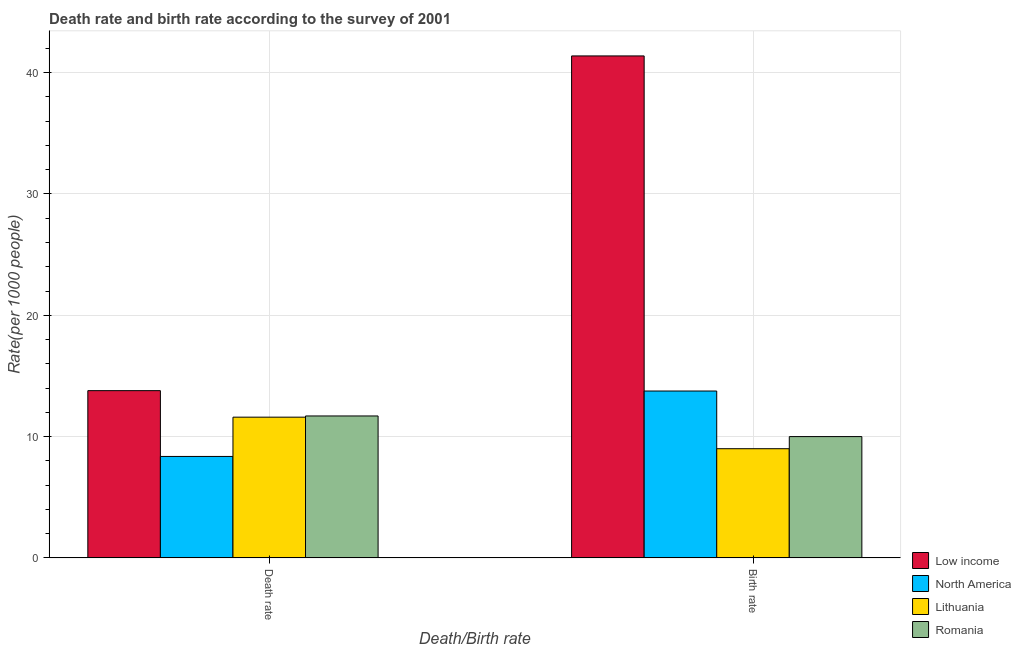How many different coloured bars are there?
Provide a succinct answer. 4. How many groups of bars are there?
Ensure brevity in your answer.  2. Are the number of bars per tick equal to the number of legend labels?
Give a very brief answer. Yes. Are the number of bars on each tick of the X-axis equal?
Make the answer very short. Yes. How many bars are there on the 1st tick from the right?
Offer a terse response. 4. What is the label of the 1st group of bars from the left?
Offer a terse response. Death rate. What is the birth rate in Low income?
Provide a succinct answer. 41.38. Across all countries, what is the maximum birth rate?
Provide a succinct answer. 41.38. Across all countries, what is the minimum birth rate?
Give a very brief answer. 9. In which country was the death rate maximum?
Your answer should be compact. Low income. In which country was the birth rate minimum?
Give a very brief answer. Lithuania. What is the total death rate in the graph?
Offer a very short reply. 45.45. What is the difference between the birth rate in Romania and that in Low income?
Ensure brevity in your answer.  -31.38. What is the difference between the death rate in North America and the birth rate in Lithuania?
Offer a very short reply. -0.64. What is the average death rate per country?
Your answer should be very brief. 11.36. What is the difference between the birth rate and death rate in Lithuania?
Give a very brief answer. -2.6. What is the ratio of the death rate in North America to that in Romania?
Provide a succinct answer. 0.71. What does the 4th bar from the left in Death rate represents?
Give a very brief answer. Romania. What does the 2nd bar from the right in Birth rate represents?
Your answer should be very brief. Lithuania. Are all the bars in the graph horizontal?
Keep it short and to the point. No. Does the graph contain grids?
Offer a terse response. Yes. What is the title of the graph?
Your response must be concise. Death rate and birth rate according to the survey of 2001. Does "Kiribati" appear as one of the legend labels in the graph?
Offer a very short reply. No. What is the label or title of the X-axis?
Offer a very short reply. Death/Birth rate. What is the label or title of the Y-axis?
Offer a terse response. Rate(per 1000 people). What is the Rate(per 1000 people) of Low income in Death rate?
Ensure brevity in your answer.  13.79. What is the Rate(per 1000 people) of North America in Death rate?
Your response must be concise. 8.36. What is the Rate(per 1000 people) of Lithuania in Death rate?
Provide a succinct answer. 11.6. What is the Rate(per 1000 people) in Romania in Death rate?
Your answer should be very brief. 11.7. What is the Rate(per 1000 people) in Low income in Birth rate?
Offer a very short reply. 41.38. What is the Rate(per 1000 people) in North America in Birth rate?
Provide a short and direct response. 13.76. What is the Rate(per 1000 people) of Romania in Birth rate?
Offer a very short reply. 10. Across all Death/Birth rate, what is the maximum Rate(per 1000 people) in Low income?
Your answer should be very brief. 41.38. Across all Death/Birth rate, what is the maximum Rate(per 1000 people) in North America?
Make the answer very short. 13.76. Across all Death/Birth rate, what is the minimum Rate(per 1000 people) of Low income?
Ensure brevity in your answer.  13.79. Across all Death/Birth rate, what is the minimum Rate(per 1000 people) in North America?
Make the answer very short. 8.36. Across all Death/Birth rate, what is the minimum Rate(per 1000 people) of Lithuania?
Your answer should be very brief. 9. Across all Death/Birth rate, what is the minimum Rate(per 1000 people) in Romania?
Your answer should be compact. 10. What is the total Rate(per 1000 people) of Low income in the graph?
Make the answer very short. 55.16. What is the total Rate(per 1000 people) of North America in the graph?
Make the answer very short. 22.12. What is the total Rate(per 1000 people) in Lithuania in the graph?
Give a very brief answer. 20.6. What is the total Rate(per 1000 people) of Romania in the graph?
Make the answer very short. 21.7. What is the difference between the Rate(per 1000 people) in Low income in Death rate and that in Birth rate?
Provide a succinct answer. -27.59. What is the difference between the Rate(per 1000 people) of North America in Death rate and that in Birth rate?
Make the answer very short. -5.39. What is the difference between the Rate(per 1000 people) of Lithuania in Death rate and that in Birth rate?
Keep it short and to the point. 2.6. What is the difference between the Rate(per 1000 people) in Low income in Death rate and the Rate(per 1000 people) in North America in Birth rate?
Keep it short and to the point. 0.03. What is the difference between the Rate(per 1000 people) of Low income in Death rate and the Rate(per 1000 people) of Lithuania in Birth rate?
Ensure brevity in your answer.  4.79. What is the difference between the Rate(per 1000 people) in Low income in Death rate and the Rate(per 1000 people) in Romania in Birth rate?
Make the answer very short. 3.79. What is the difference between the Rate(per 1000 people) of North America in Death rate and the Rate(per 1000 people) of Lithuania in Birth rate?
Your answer should be very brief. -0.64. What is the difference between the Rate(per 1000 people) of North America in Death rate and the Rate(per 1000 people) of Romania in Birth rate?
Provide a succinct answer. -1.64. What is the difference between the Rate(per 1000 people) in Lithuania in Death rate and the Rate(per 1000 people) in Romania in Birth rate?
Your response must be concise. 1.6. What is the average Rate(per 1000 people) of Low income per Death/Birth rate?
Make the answer very short. 27.58. What is the average Rate(per 1000 people) in North America per Death/Birth rate?
Offer a very short reply. 11.06. What is the average Rate(per 1000 people) of Lithuania per Death/Birth rate?
Your answer should be very brief. 10.3. What is the average Rate(per 1000 people) in Romania per Death/Birth rate?
Your answer should be compact. 10.85. What is the difference between the Rate(per 1000 people) of Low income and Rate(per 1000 people) of North America in Death rate?
Give a very brief answer. 5.42. What is the difference between the Rate(per 1000 people) in Low income and Rate(per 1000 people) in Lithuania in Death rate?
Offer a terse response. 2.19. What is the difference between the Rate(per 1000 people) in Low income and Rate(per 1000 people) in Romania in Death rate?
Offer a terse response. 2.09. What is the difference between the Rate(per 1000 people) in North America and Rate(per 1000 people) in Lithuania in Death rate?
Your answer should be very brief. -3.24. What is the difference between the Rate(per 1000 people) of North America and Rate(per 1000 people) of Romania in Death rate?
Ensure brevity in your answer.  -3.34. What is the difference between the Rate(per 1000 people) of Low income and Rate(per 1000 people) of North America in Birth rate?
Provide a succinct answer. 27.62. What is the difference between the Rate(per 1000 people) of Low income and Rate(per 1000 people) of Lithuania in Birth rate?
Offer a terse response. 32.38. What is the difference between the Rate(per 1000 people) of Low income and Rate(per 1000 people) of Romania in Birth rate?
Provide a succinct answer. 31.38. What is the difference between the Rate(per 1000 people) of North America and Rate(per 1000 people) of Lithuania in Birth rate?
Ensure brevity in your answer.  4.76. What is the difference between the Rate(per 1000 people) in North America and Rate(per 1000 people) in Romania in Birth rate?
Give a very brief answer. 3.76. What is the ratio of the Rate(per 1000 people) in Low income in Death rate to that in Birth rate?
Provide a short and direct response. 0.33. What is the ratio of the Rate(per 1000 people) of North America in Death rate to that in Birth rate?
Provide a short and direct response. 0.61. What is the ratio of the Rate(per 1000 people) of Lithuania in Death rate to that in Birth rate?
Make the answer very short. 1.29. What is the ratio of the Rate(per 1000 people) in Romania in Death rate to that in Birth rate?
Give a very brief answer. 1.17. What is the difference between the highest and the second highest Rate(per 1000 people) of Low income?
Keep it short and to the point. 27.59. What is the difference between the highest and the second highest Rate(per 1000 people) in North America?
Your response must be concise. 5.39. What is the difference between the highest and the lowest Rate(per 1000 people) in Low income?
Provide a short and direct response. 27.59. What is the difference between the highest and the lowest Rate(per 1000 people) of North America?
Offer a very short reply. 5.39. What is the difference between the highest and the lowest Rate(per 1000 people) in Romania?
Give a very brief answer. 1.7. 